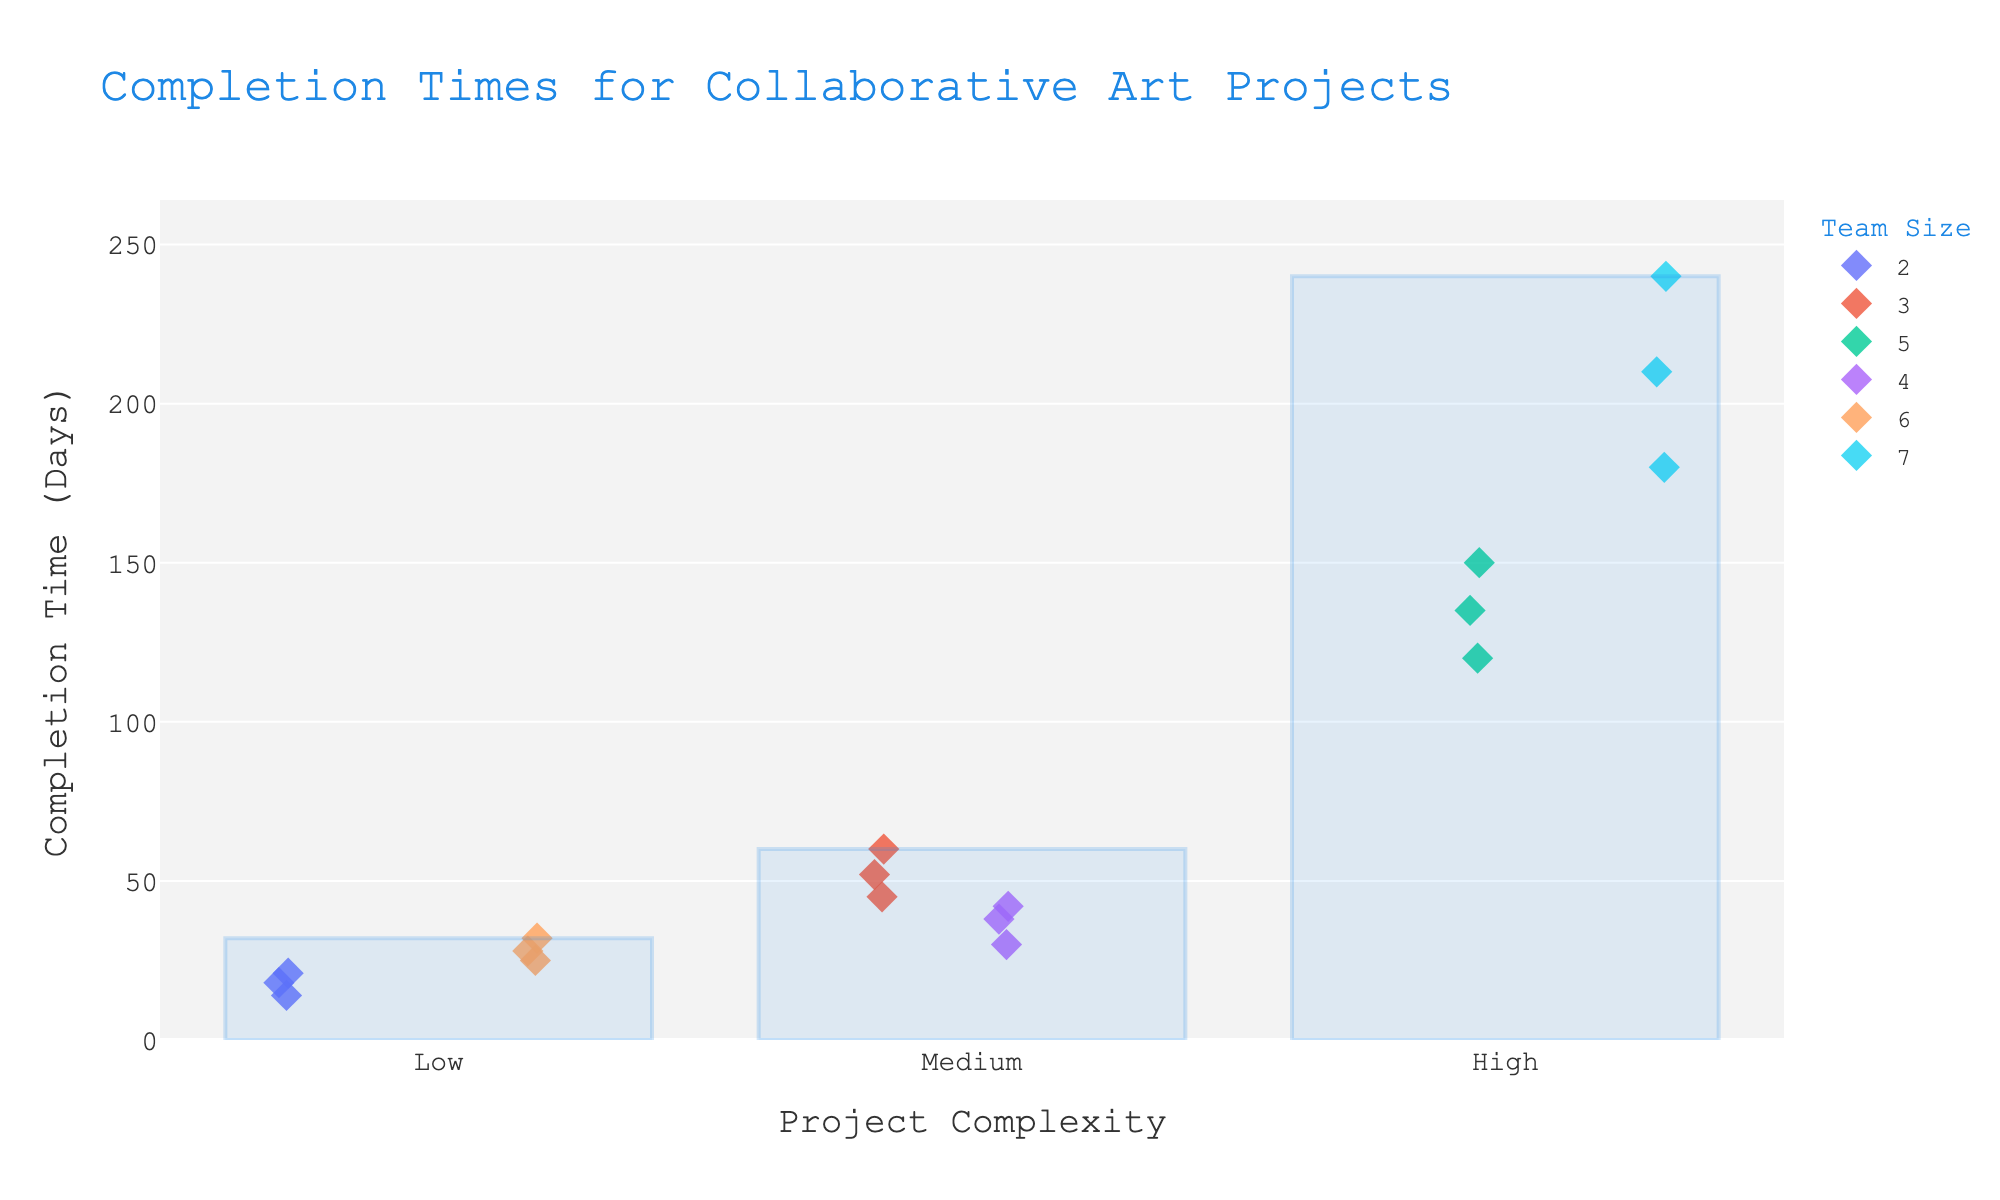What are the three levels of project complexity displayed in the figure? The figure has three distinct markers for project complexity, labeled on the x-axis. These levels are "Low," "Medium," and "High."
Answer: Low, Medium, High How many projects are displayed in the "High" complexity category? By looking at the "High" complexity section of the plot, we can count the data points displayed. There are six project completion times shown for the "High" complexity category.
Answer: 6 What is the completion time range for projects with "Low" complexity? For "Low" complexity projects, the y-values on the plot represent completion times. By observing the minimum and maximum points, we see the range spans from 14 to 32 days.
Answer: 14 to 32 days What is the general trend in completion time as project complexity increases? By observing the plot, there is a noticeable trend that as project complexity shifts from "Low" to "Medium" to "High," the range of completion times becomes wider and shifts to higher values, indicating increasing time requirements for more complex projects.
Answer: Increasing Which team size had the highest recorded completion time and what was it? By finding the highest point on the "High" complexity section and noting the team size color/marker, the maximum completion time is 240 days by a team of 7 members.
Answer: 7, 240 days Compare the completion times for "Medium" complexity projects in terms of range for a 3-person team versus a 4-person team. By comparing the "Medium" complexity completion times for teams of 3 and 4, we see that the 3-person team has completion times ranging from 45 to 60 days while the 4-person team ranges from 30 to 42 days.
Answer: 3-person 45-60 days; 4-person 30-42 days What is the average completion time for "Medium" complexity projects done by a team of 4? The completion times for a team of 4 in the "Medium" complexity are 30, 38, and 42. Summing these up gives (30 + 38 + 42) = 110. Dividing by the number of projects (3) results in an average of 110 / 3 ≈ 37 days.
Answer: 37 days Which complexity level has the smallest range of project completion times? By observing the spread of points on the y-axis for each complexity level, the "Low" complexity level has the smallest range (32-14 = 18 days).
Answer: Low Do projects that involve larger team sizes always have shorter completion times? Observing the plot, larger team sizes do not always translate to shorter completion times. For example, "High" complexity projects with team sizes of 5 and 7 have significantly longer completion times compared to smaller teams in "Medium" complexity.
Answer: No 